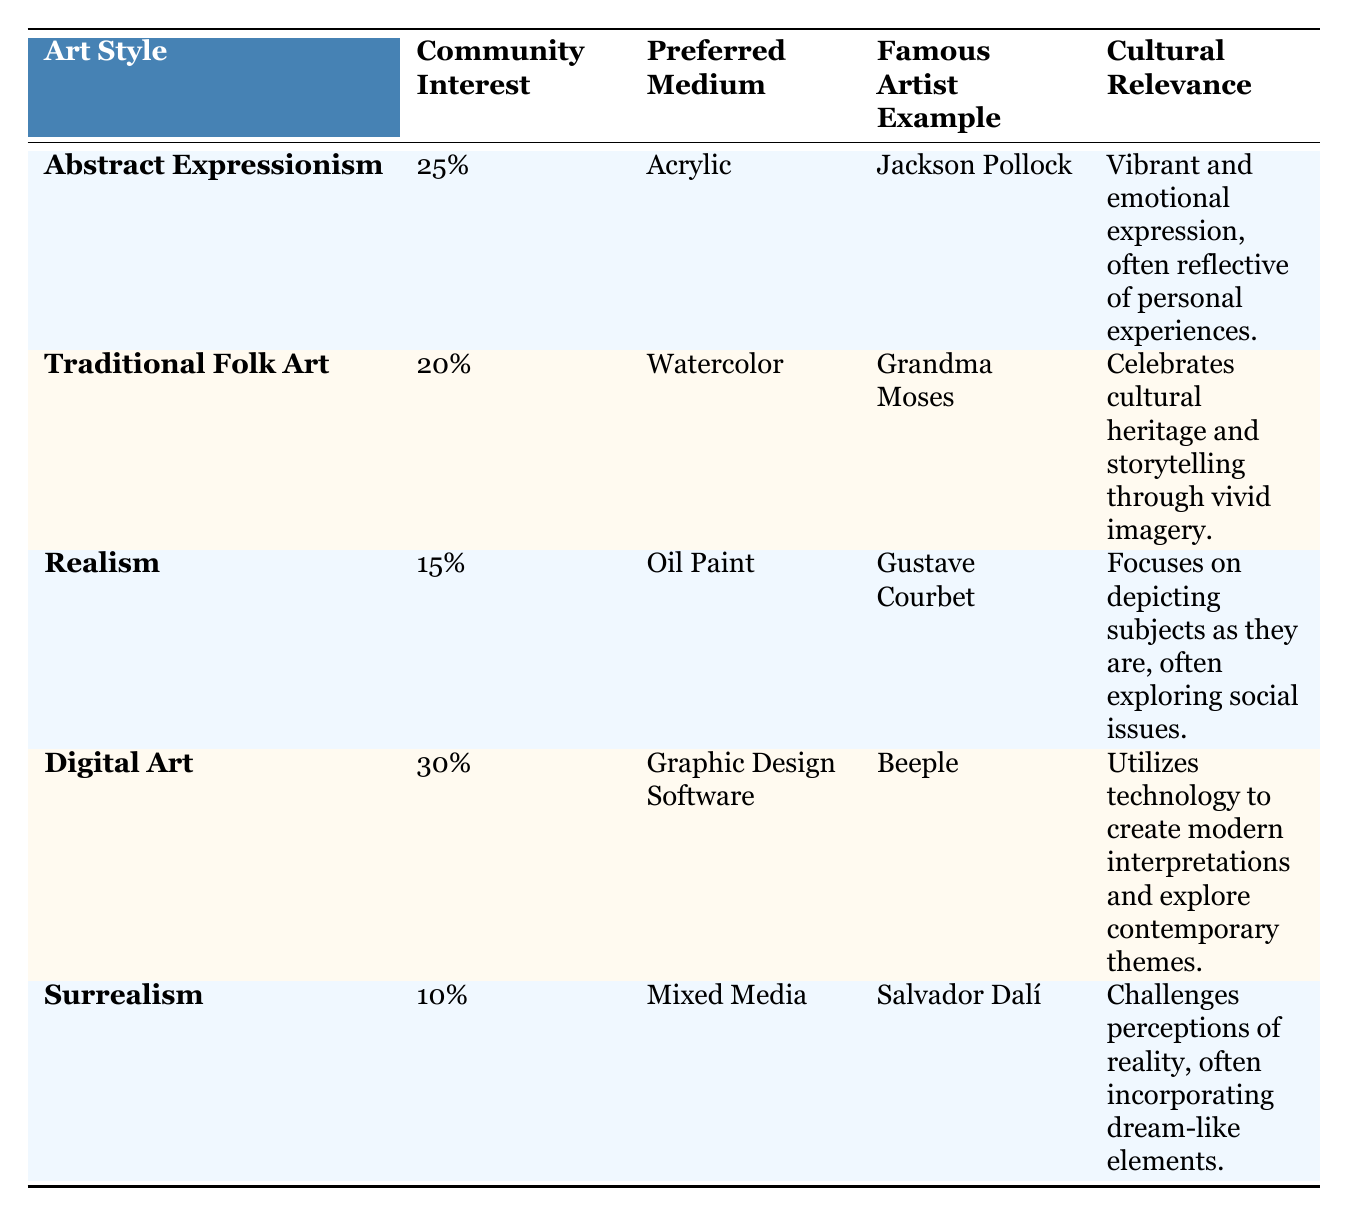What is the community interest percentage for Digital Art? The community interest percentage for Digital Art is stated directly in the table as 30%.
Answer: 30% Which art style has the highest community interest percentage? The table shows that Digital Art has the highest community interest percentage at 30%.
Answer: Digital Art What is the preferred medium for Traditional Folk Art? The table lists Watercolor as the preferred medium for Traditional Folk Art.
Answer: Watercolor Is there an art style that has a community interest percentage of 15%? Yes, the table indicates that Realism has a community interest percentage of 15%.
Answer: Yes Which two art styles emphasize emotional expression and cultural storytelling? Abstract Expressionism focuses on emotional expression, while Traditional Folk Art emphasizes cultural storytelling. Both are mentioned in the cultural relevance column of the table.
Answer: Abstract Expressionism and Traditional Folk Art What is the total community interest percentage for Abstract Expressionism and Realism combined? Adding the community interest percentages for Abstract Expressionism (25%) and Realism (15%) gives 25 + 15 = 40%.
Answer: 40% Which famous artist is associated with the art style of Realism? The table indicates that Gustave Courbet is the famous artist example associated with Realism.
Answer: Gustave Courbet Does Surrealism have a preferred medium different from the others? Yes, Surrealism uses Mixed Media as its preferred medium, which is different from the other mediums listed (Acrylic, Watercolor, Oil Paint, Graphic Design Software).
Answer: Yes What percentage difference in community interest is there between Digital Art and Surrealism? Digital Art has a community interest percentage of 30%, and Surrealism has 10%, so the difference is 30 - 10 = 20%.
Answer: 20% 